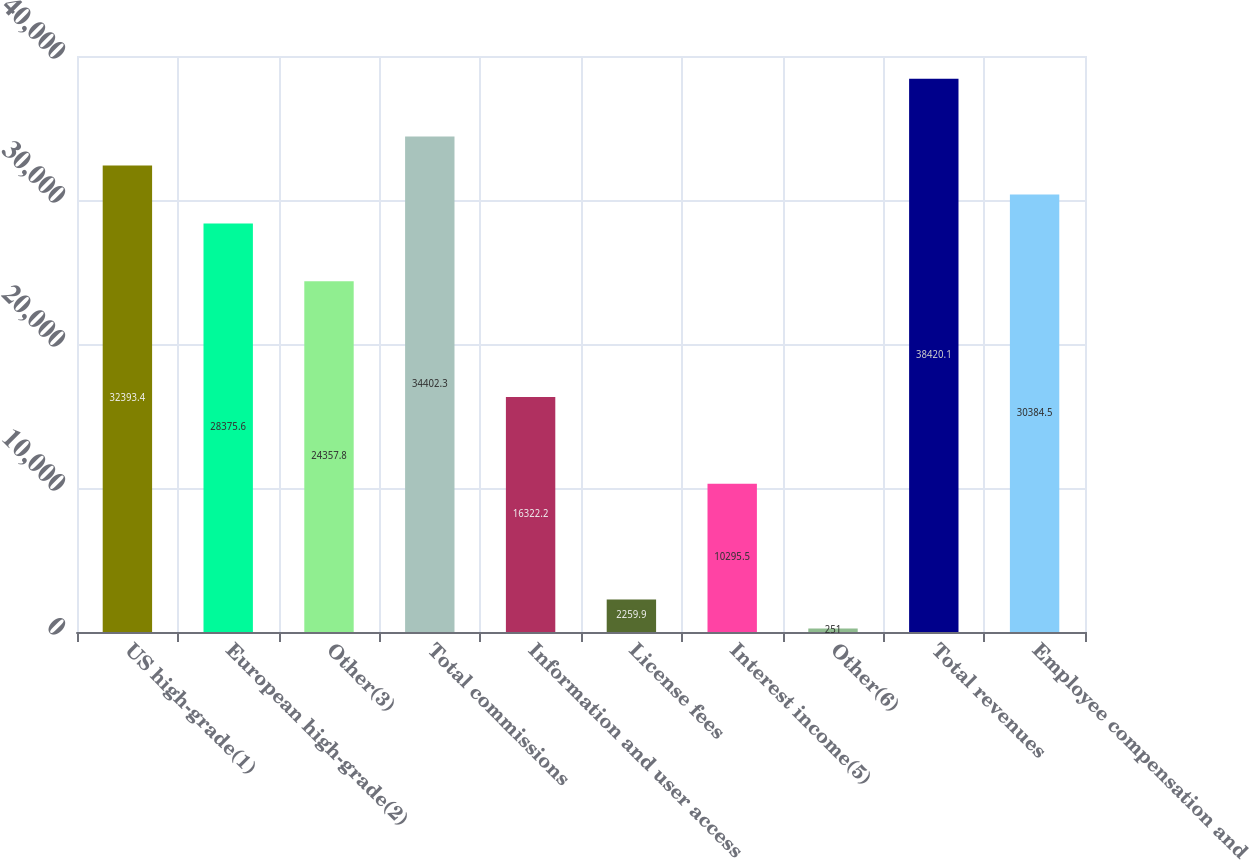Convert chart. <chart><loc_0><loc_0><loc_500><loc_500><bar_chart><fcel>US high-grade(1)<fcel>European high-grade(2)<fcel>Other(3)<fcel>Total commissions<fcel>Information and user access<fcel>License fees<fcel>Interest income(5)<fcel>Other(6)<fcel>Total revenues<fcel>Employee compensation and<nl><fcel>32393.4<fcel>28375.6<fcel>24357.8<fcel>34402.3<fcel>16322.2<fcel>2259.9<fcel>10295.5<fcel>251<fcel>38420.1<fcel>30384.5<nl></chart> 